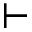Convert formula to latex. <formula><loc_0><loc_0><loc_500><loc_500>\vdash</formula> 